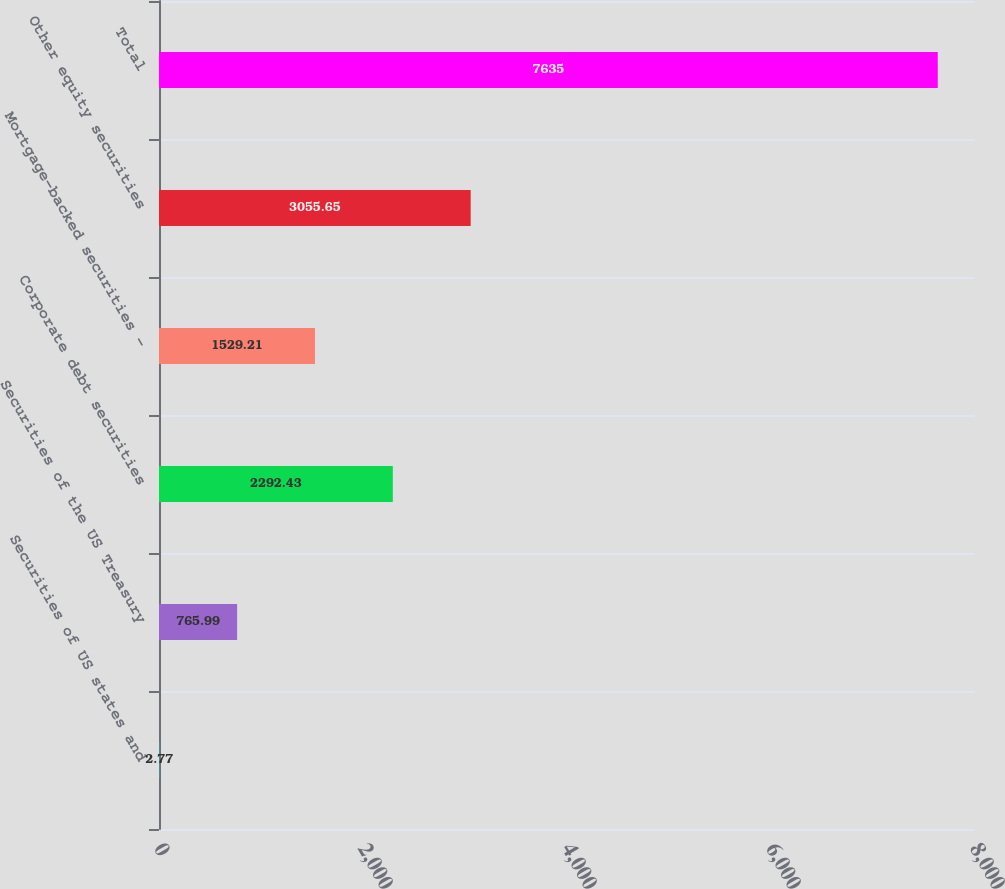Convert chart. <chart><loc_0><loc_0><loc_500><loc_500><bar_chart><fcel>Securities of US states and<fcel>Securities of the US Treasury<fcel>Corporate debt securities<fcel>Mortgage-backed securities -<fcel>Other equity securities<fcel>Total<nl><fcel>2.77<fcel>765.99<fcel>2292.43<fcel>1529.21<fcel>3055.65<fcel>7635<nl></chart> 